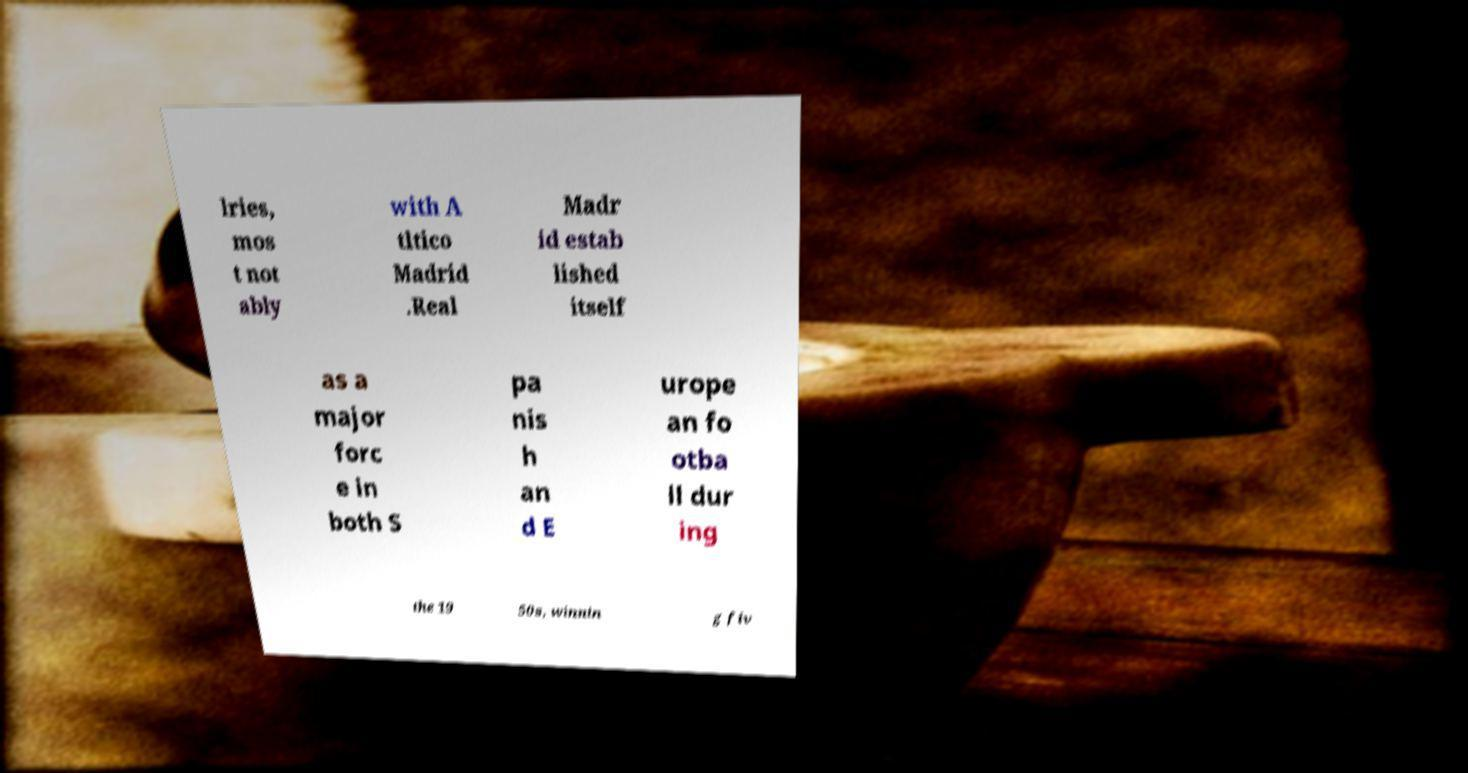What messages or text are displayed in this image? I need them in a readable, typed format. lries, mos t not ably with A tltico Madrid .Real Madr id estab lished itself as a major forc e in both S pa nis h an d E urope an fo otba ll dur ing the 19 50s, winnin g fiv 